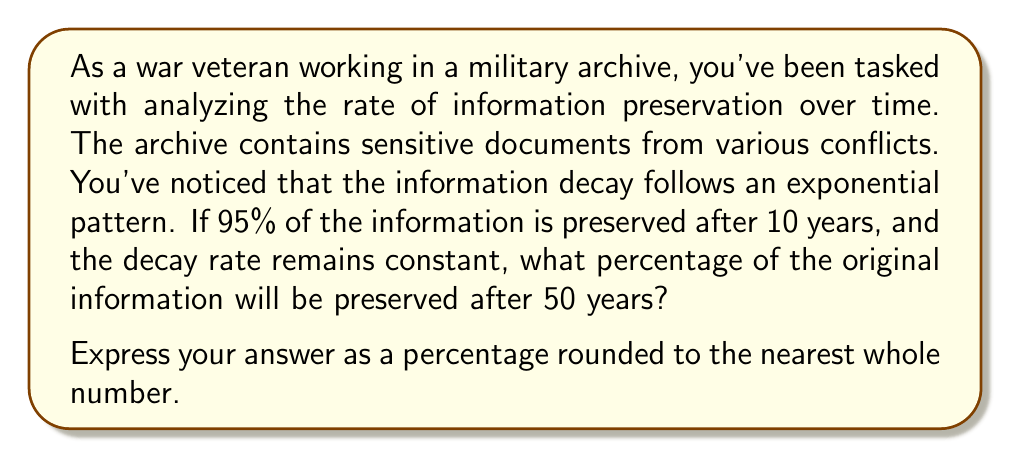Help me with this question. Let's approach this step-by-step:

1) Let $P(t)$ be the percentage of information preserved after $t$ years.

2) We know that after 10 years, 95% of the information is preserved. This gives us:

   $P(10) = 95\%$ or $0.95$ in decimal form

3) The general form of exponential decay is:

   $P(t) = 100 \cdot b^t$

   where $b$ is the base of the exponential function (a number between 0 and 1).

4) We can find $b$ using the given information:

   $0.95 = 100 \cdot b^{10}$
   $0.0095 = b^{10}$
   $b = (0.0095)^{\frac{1}{10}} \approx 0.9948$

5) Now we have our complete function:

   $P(t) = 100 \cdot (0.9948)^t$

6) To find the percentage preserved after 50 years, we calculate:

   $P(50) = 100 \cdot (0.9948)^{50} \approx 77.12\%$

7) Rounding to the nearest whole number: 77%
Answer: 77% 